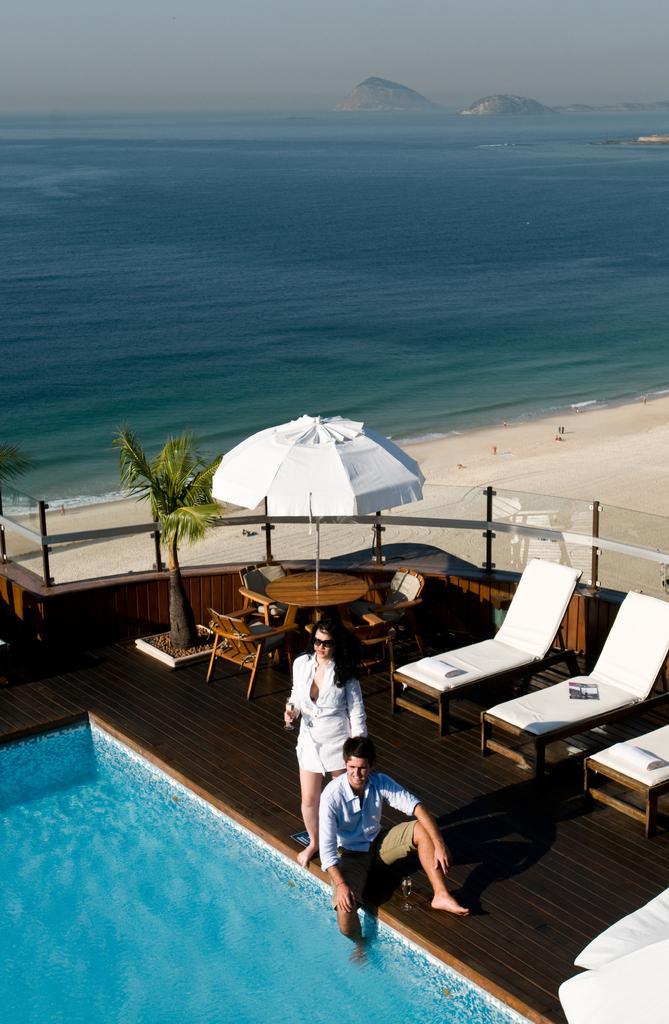Describe this image in one or two sentences. In this picture I can see a person sitting and a person standing on the side of a swimming pool. I can see deck chairs on the right side. I can see sitting chair and table. I can see the tent. I can see sand. I can see sand. I can see water. I can see mountains in the background. I can see clouds in the sky. I can see trees on the left side. 